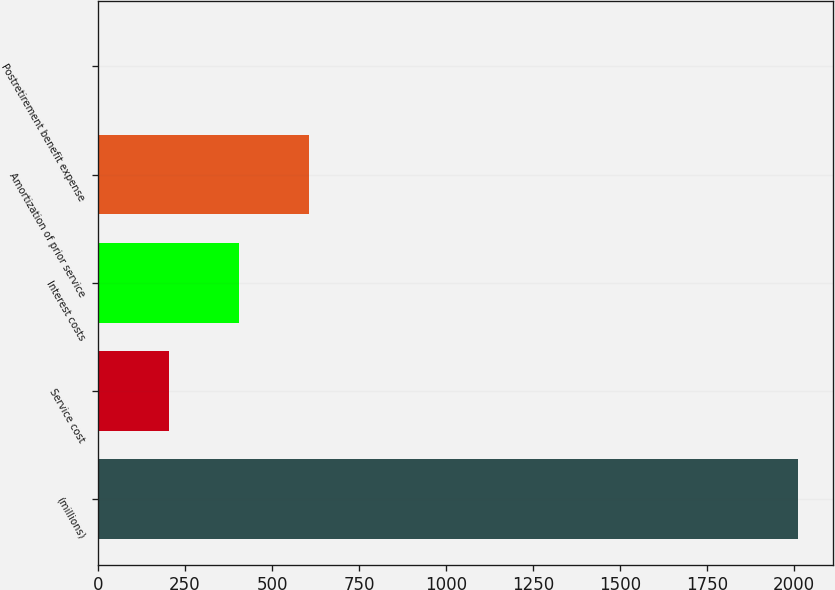Convert chart to OTSL. <chart><loc_0><loc_0><loc_500><loc_500><bar_chart><fcel>(millions)<fcel>Service cost<fcel>Interest costs<fcel>Amortization of prior service<fcel>Postretirement benefit expense<nl><fcel>2011<fcel>204.16<fcel>404.92<fcel>605.68<fcel>3.4<nl></chart> 